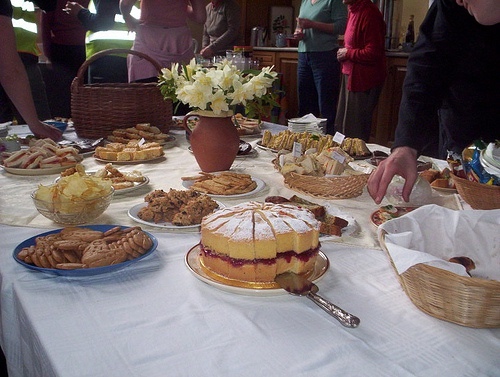Describe the objects in this image and their specific colors. I can see dining table in black, darkgray, lightgray, and gray tones, people in black, brown, and maroon tones, cake in black, tan, gray, lightgray, and brown tones, handbag in black, maroon, and purple tones, and people in black, maroon, and brown tones in this image. 